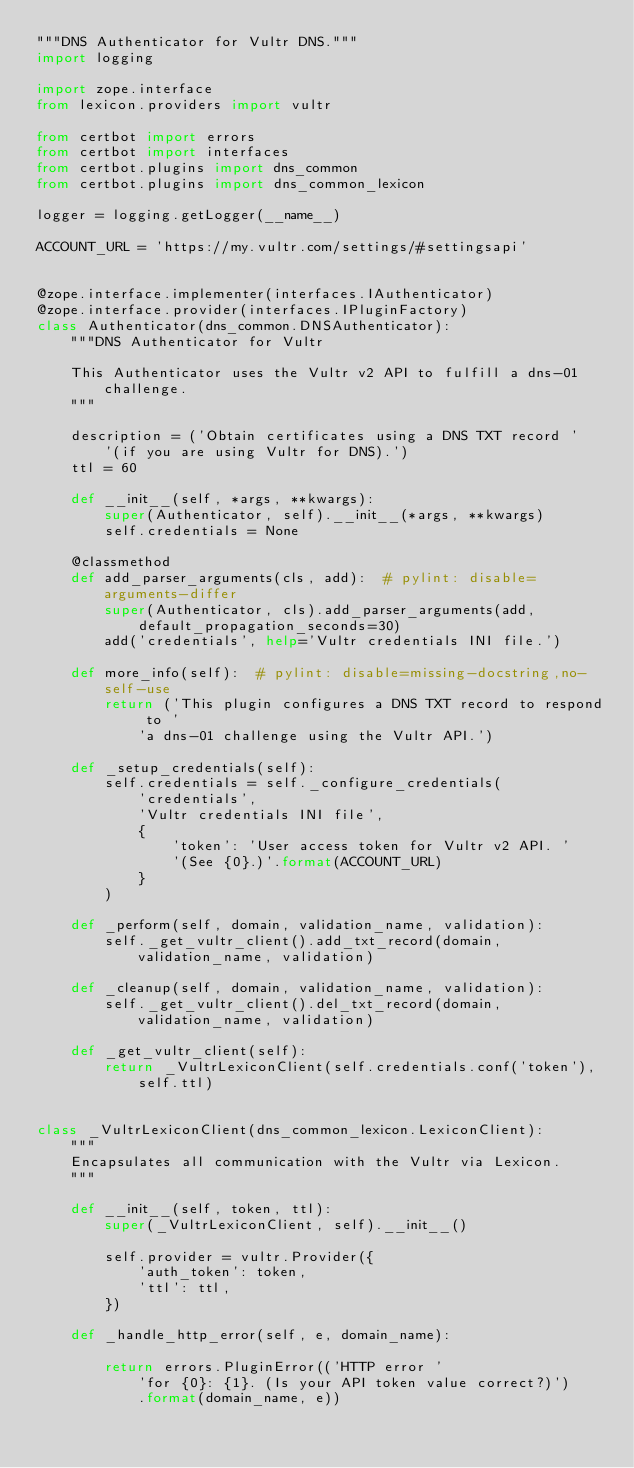<code> <loc_0><loc_0><loc_500><loc_500><_Python_>"""DNS Authenticator for Vultr DNS."""
import logging

import zope.interface
from lexicon.providers import vultr

from certbot import errors
from certbot import interfaces
from certbot.plugins import dns_common
from certbot.plugins import dns_common_lexicon

logger = logging.getLogger(__name__)

ACCOUNT_URL = 'https://my.vultr.com/settings/#settingsapi'


@zope.interface.implementer(interfaces.IAuthenticator)
@zope.interface.provider(interfaces.IPluginFactory)
class Authenticator(dns_common.DNSAuthenticator):
    """DNS Authenticator for Vultr

    This Authenticator uses the Vultr v2 API to fulfill a dns-01 challenge.
    """

    description = ('Obtain certificates using a DNS TXT record '
        '(if you are using Vultr for DNS).')
    ttl = 60

    def __init__(self, *args, **kwargs):
        super(Authenticator, self).__init__(*args, **kwargs)
        self.credentials = None

    @classmethod
    def add_parser_arguments(cls, add):  # pylint: disable=arguments-differ
        super(Authenticator, cls).add_parser_arguments(add, 
            default_propagation_seconds=30)
        add('credentials', help='Vultr credentials INI file.')

    def more_info(self):  # pylint: disable=missing-docstring,no-self-use
        return ('This plugin configures a DNS TXT record to respond to '
            'a dns-01 challenge using the Vultr API.')

    def _setup_credentials(self):
        self.credentials = self._configure_credentials(
            'credentials',
            'Vultr credentials INI file',
            {
                'token': 'User access token for Vultr v2 API. '
                '(See {0}.)'.format(ACCOUNT_URL)
            }
        )

    def _perform(self, domain, validation_name, validation):
        self._get_vultr_client().add_txt_record(domain, validation_name, validation)

    def _cleanup(self, domain, validation_name, validation):
        self._get_vultr_client().del_txt_record(domain, validation_name, validation)

    def _get_vultr_client(self):
        return _VultrLexiconClient(self.credentials.conf('token'), self.ttl)


class _VultrLexiconClient(dns_common_lexicon.LexiconClient):
    """
    Encapsulates all communication with the Vultr via Lexicon.
    """

    def __init__(self, token, ttl):
        super(_VultrLexiconClient, self).__init__()

        self.provider = vultr.Provider({
            'auth_token': token,
            'ttl': ttl,
        })

    def _handle_http_error(self, e, domain_name):

        return errors.PluginError(('HTTP error '
            'for {0}: {1}. (Is your API token value correct?)')
            .format(domain_name, e))
</code> 